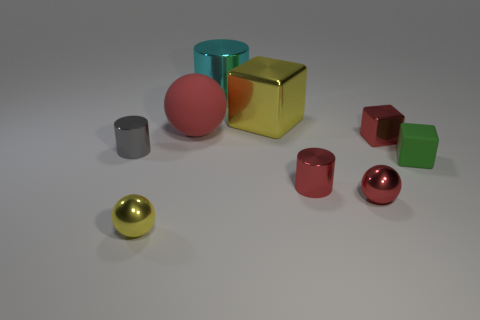Subtract all purple cubes. Subtract all red cylinders. How many cubes are left? 3 Add 1 tiny shiny blocks. How many objects exist? 10 Subtract all cylinders. How many objects are left? 6 Subtract all large cylinders. Subtract all shiny cylinders. How many objects are left? 5 Add 4 small red metal things. How many small red metal things are left? 7 Add 4 large red rubber blocks. How many large red rubber blocks exist? 4 Subtract 0 yellow cylinders. How many objects are left? 9 